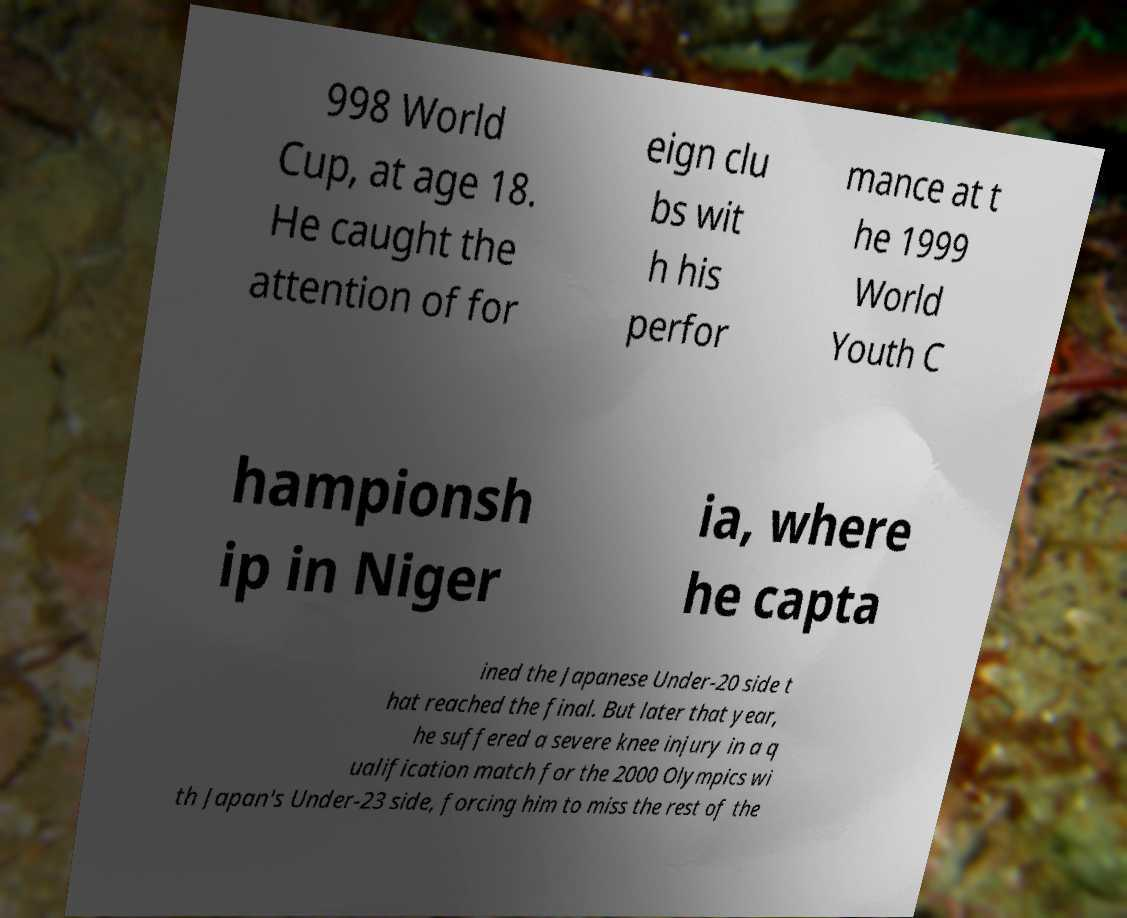There's text embedded in this image that I need extracted. Can you transcribe it verbatim? 998 World Cup, at age 18. He caught the attention of for eign clu bs wit h his perfor mance at t he 1999 World Youth C hampionsh ip in Niger ia, where he capta ined the Japanese Under-20 side t hat reached the final. But later that year, he suffered a severe knee injury in a q ualification match for the 2000 Olympics wi th Japan's Under-23 side, forcing him to miss the rest of the 